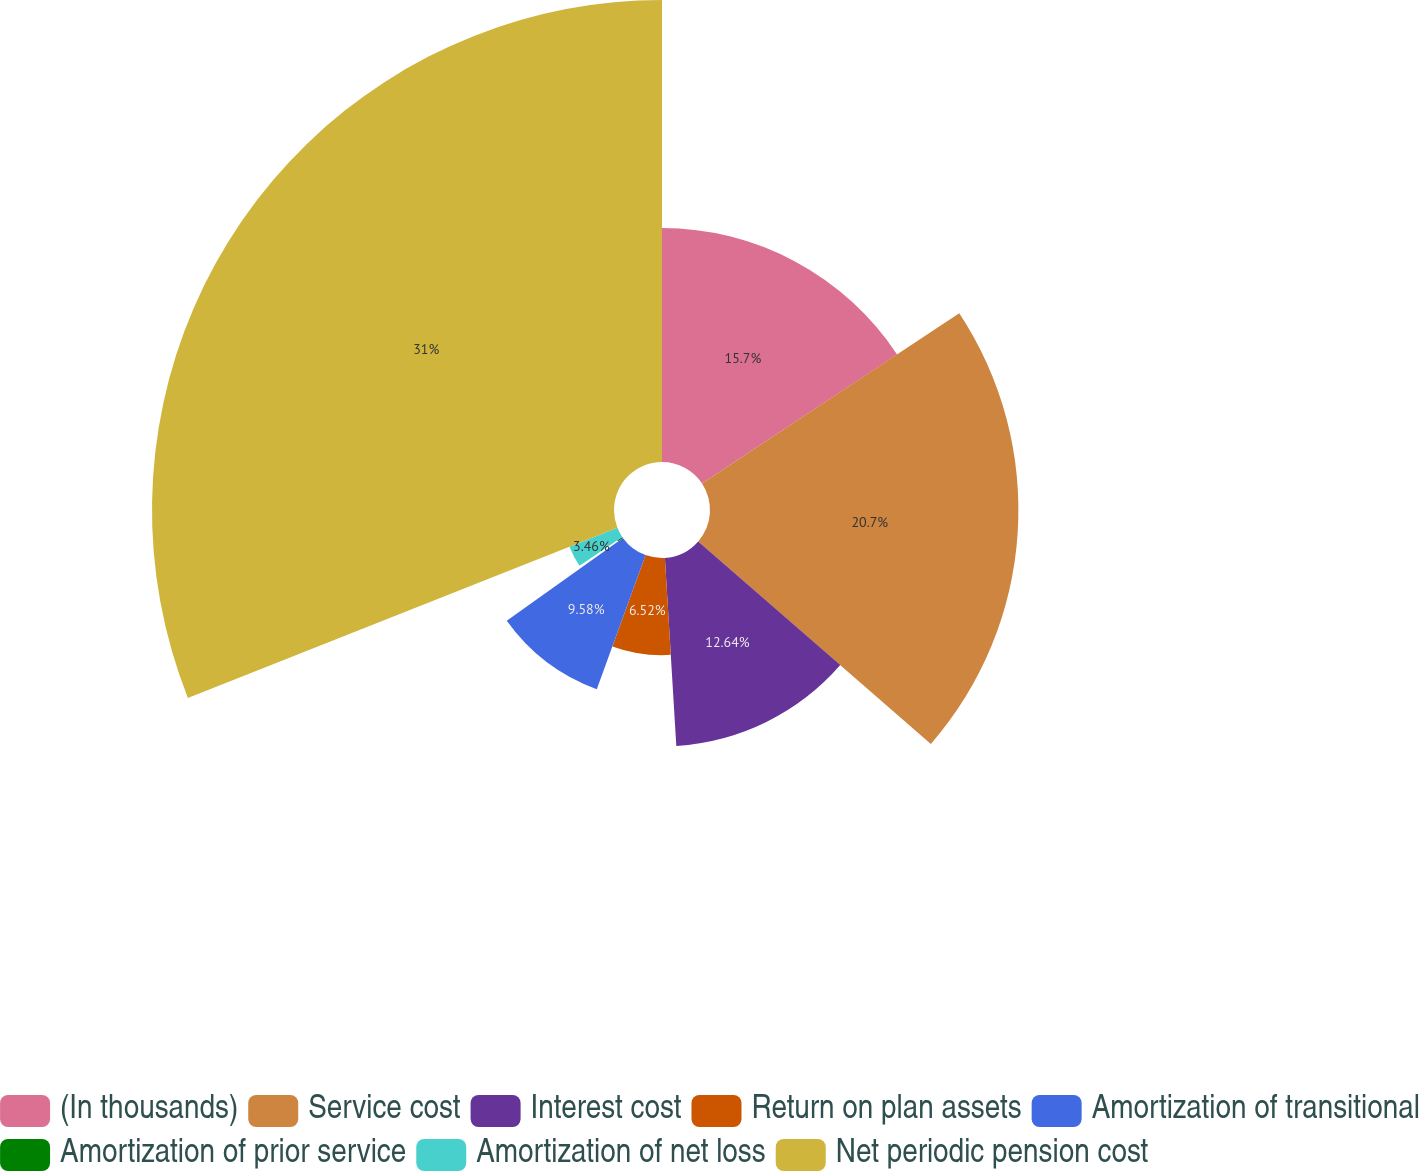Convert chart. <chart><loc_0><loc_0><loc_500><loc_500><pie_chart><fcel>(In thousands)<fcel>Service cost<fcel>Interest cost<fcel>Return on plan assets<fcel>Amortization of transitional<fcel>Amortization of prior service<fcel>Amortization of net loss<fcel>Net periodic pension cost<nl><fcel>15.7%<fcel>20.7%<fcel>12.64%<fcel>6.52%<fcel>9.58%<fcel>0.4%<fcel>3.46%<fcel>31.01%<nl></chart> 